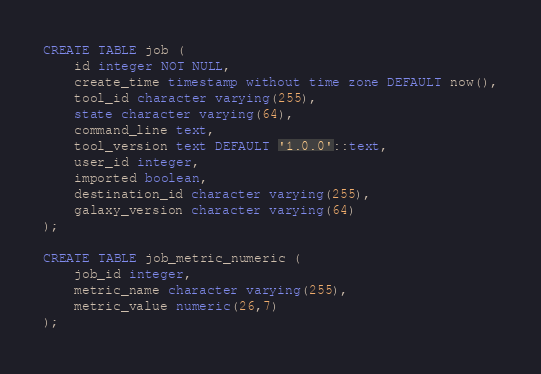Convert code to text. <code><loc_0><loc_0><loc_500><loc_500><_SQL_>CREATE TABLE job (
    id integer NOT NULL,
    create_time timestamp without time zone DEFAULT now(),
    tool_id character varying(255),
    state character varying(64),
    command_line text,
    tool_version text DEFAULT '1.0.0'::text,
    user_id integer,
    imported boolean,
    destination_id character varying(255),
    galaxy_version character varying(64)
);

CREATE TABLE job_metric_numeric (
    job_id integer,
    metric_name character varying(255),
    metric_value numeric(26,7)
);
</code> 